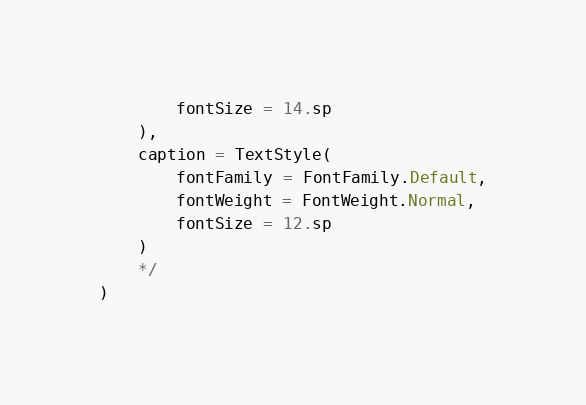Convert code to text. <code><loc_0><loc_0><loc_500><loc_500><_Kotlin_>        fontSize = 14.sp
    ),
    caption = TextStyle(
        fontFamily = FontFamily.Default,
        fontWeight = FontWeight.Normal,
        fontSize = 12.sp
    )
    */
)
</code> 